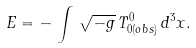Convert formula to latex. <formula><loc_0><loc_0><loc_500><loc_500>E = - \, \int \, \sqrt { - g } \, T _ { 0 ( o b s ) } ^ { 0 } \, d ^ { 3 } x .</formula> 